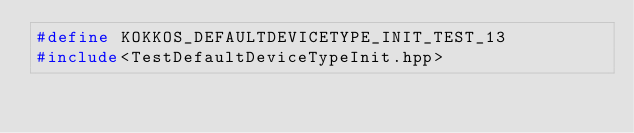<code> <loc_0><loc_0><loc_500><loc_500><_C++_>#define KOKKOS_DEFAULTDEVICETYPE_INIT_TEST_13
#include<TestDefaultDeviceTypeInit.hpp>
</code> 